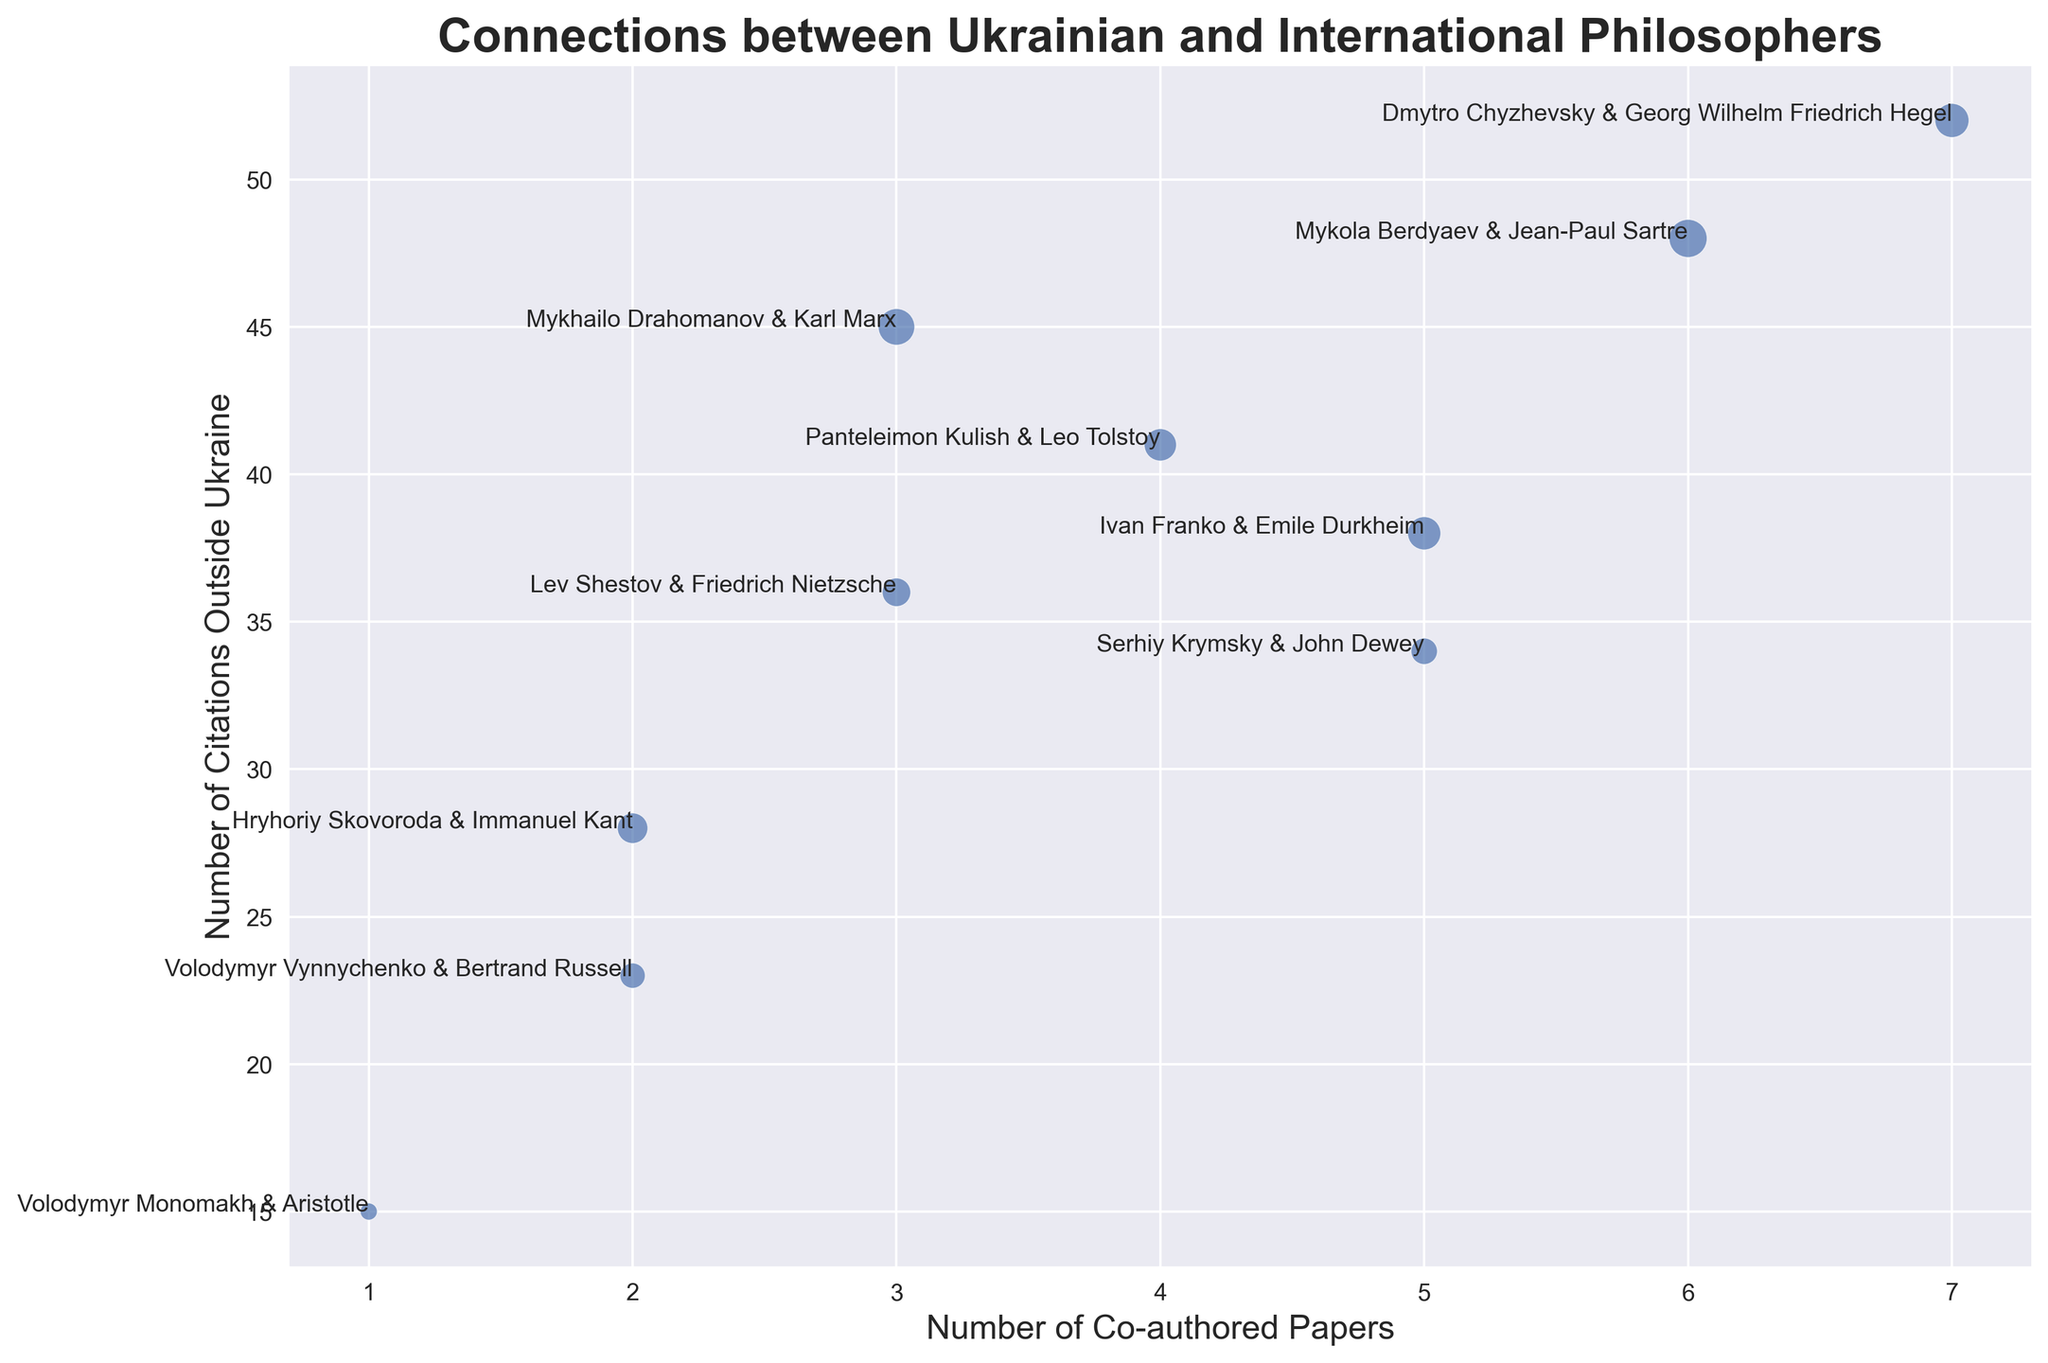What is the total number of co-authored papers between all authors? First, add the number of co-authored papers for each pair: 5 (Krymsky & Dewey) + 3 (Drahomanov & Marx) + 2 (Skovoroda & Kant) + 1 (Monomakh & Aristotle) + 4 (Kulish & Tolstoy) + 7 (Chyzhevsky & Hegel) + 6 (Berdyaev & Sartre) + 3 (Shestov & Nietzsche) + 2 (Vynnychenko & Russell) + 5 (Franko & Durkheim). This sums up to 38.
Answer: 38 Which pair of authors has the highest number of co-authored papers? Among the pairs, Dmytro Chyzhevsky and Georg Wilhelm Friedrich Hegel have 7 co-authored papers, which is the highest.
Answer: Chyzhevsky & Hegel Which pair has the highest number of citations outside Ukraine? By examining the citations outside Ukraine, Dmytro Chyzhevsky and Georg Wilhelm Friedrich Hegel again stand out with 52 citations, the highest among all pairs.
Answer: Chyzhevsky & Hegel What is the average number of citations within Ukraine for all author pairs? Add up all the citations within Ukraine: 12 + 23 + 16 + 5 + 18 + 20 + 25 + 14 + 11 + 19. This sums to 163. Then, divide by the number of pairs (10): 163 / 10 = 16.3.
Answer: 16.3 Which pair has the smallest marker size in the plot? The marker size is scaled by the number of citations in Ukraine. Volodymyr Monomakh and Aristotle have the smallest number of citations (5), resulting in the smallest marker size.
Answer: Monomakh & Aristotle How many pairs have at least three co-authored papers? Counting pairs with three or more co-authored papers: Krymsky & Dewey (5), Drahomanov & Marx (3), Kulish & Tolstoy (4), Chyzhevsky & Hegel (7), Berdyaev & Sartre (6), Shestov & Nietzsche (3), and Franko & Durkheim (5). There are 7 pairs meeting this criterion.
Answer: 7 Who are the authors in the pair with 20 citations in Ukraine? The pair with exactly 20 citations in Ukraine is Dmytro Chyzhevsky and Georg Wilhelm Friedrich Hegel.
Answer: Chyzhevsky & Hegel How much larger is the number of citations outside Ukraine for Panteleimon Kulish and Leo Tolstoy compared to their citations within Ukraine? The number of citations outside Ukraine for Kulish & Tolstoy is 41 and within Ukraine is 18. Calculate the difference: 41 - 18 = 23.
Answer: 23 What is the relationship between the number of co-authored papers and citations outside Ukraine for the pair with the highest citations within Ukraine? Chyzhevsky and Hegel have the highest citations within Ukraine (20). They have 7 co-authored papers and 52 citations outside Ukraine.
Answer: 7 co-authored papers and 52 citations outside Ukraine Are there any noticeable patterns in the data regarding the size of the markers and their respective locations on the scatter plot? Larger markers are generally associated with higher citations within Ukraine, and their locations vary across the number of co-authored papers and citations outside Ukraine axes without a very strong pattern.
Answer: Larger markers, varying locations 